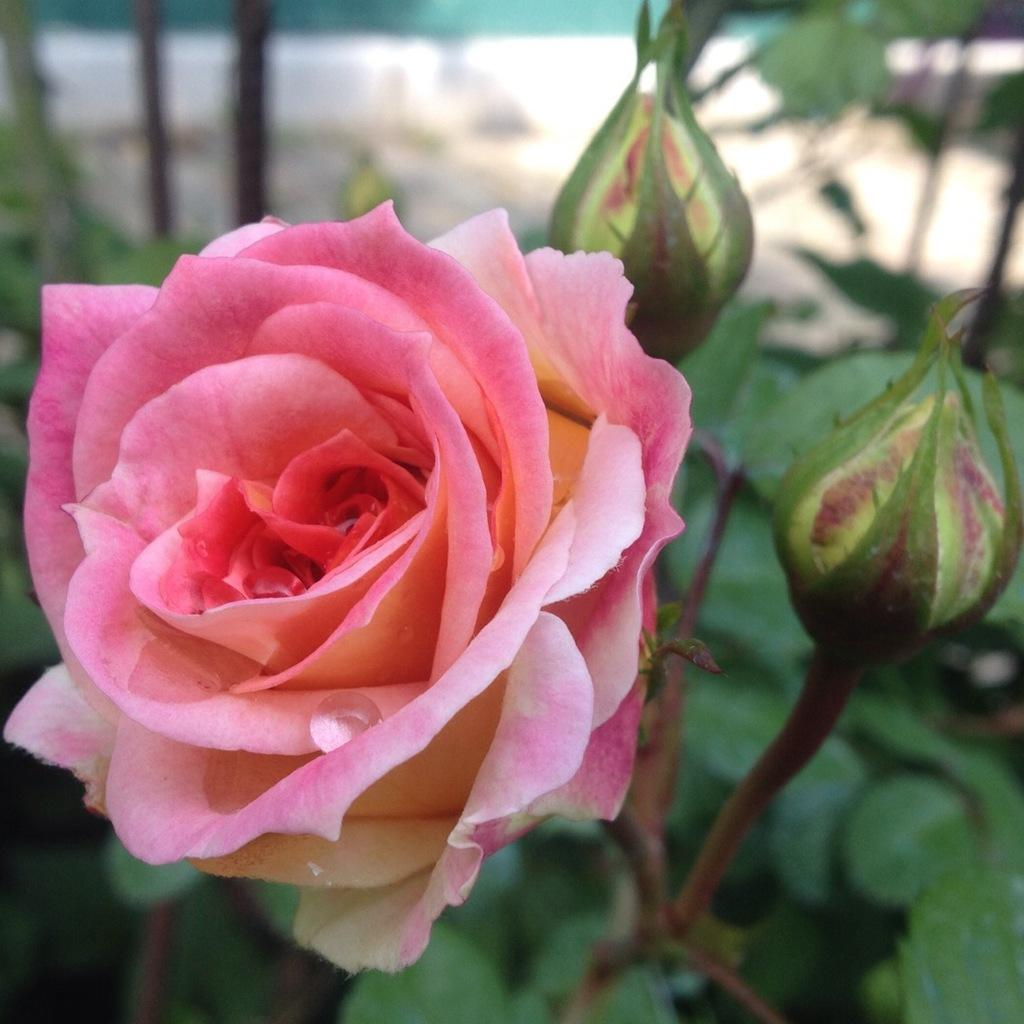What type of flower is in the image? There is a rose in the image. What stage of growth are the rose's buds in? The buds on the stem of the rose are not yet fully bloomed. What other plant elements can be seen in the image? There are leaves in the background of the image. How would you describe the background of the image? The background is blurry. How does the rose crack in the image? The rose does not crack in the image; it is a complete flower with buds on its stem. 